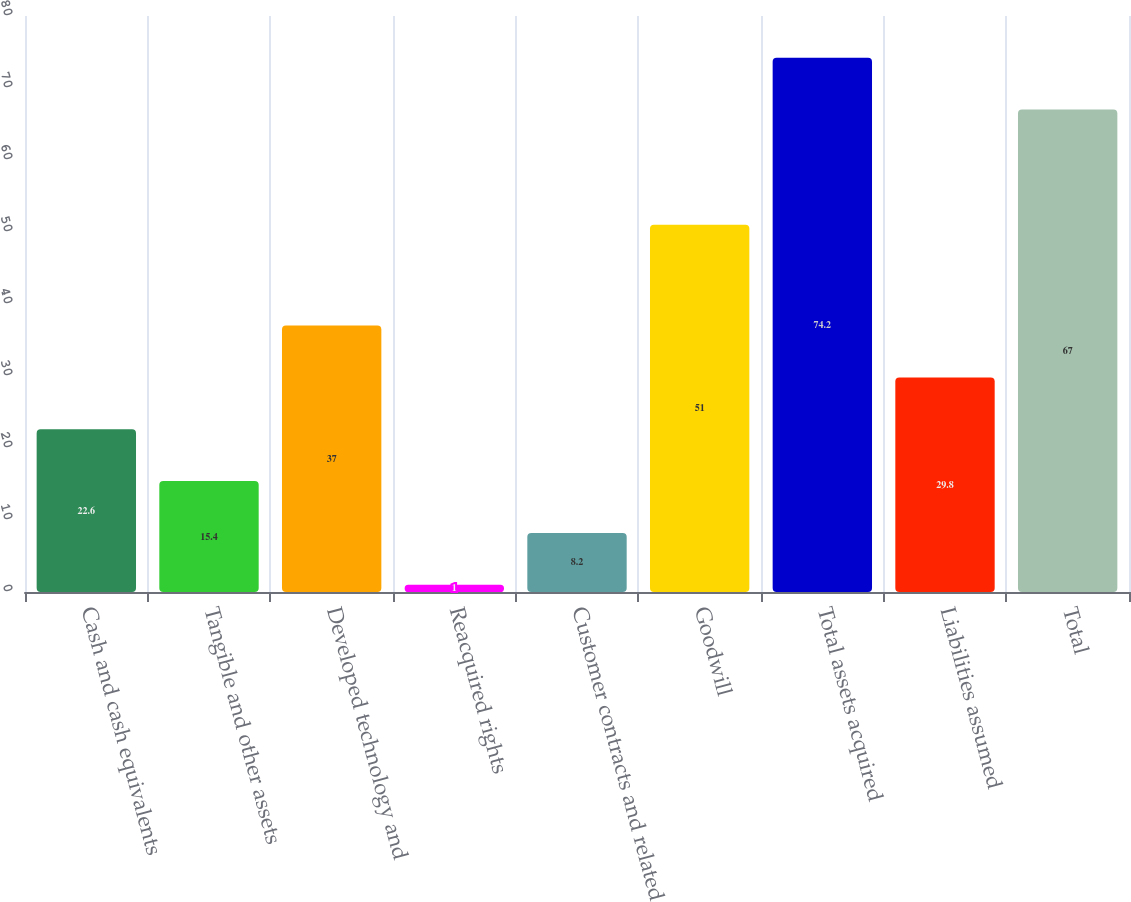Convert chart. <chart><loc_0><loc_0><loc_500><loc_500><bar_chart><fcel>Cash and cash equivalents<fcel>Tangible and other assets<fcel>Developed technology and<fcel>Reacquired rights<fcel>Customer contracts and related<fcel>Goodwill<fcel>Total assets acquired<fcel>Liabilities assumed<fcel>Total<nl><fcel>22.6<fcel>15.4<fcel>37<fcel>1<fcel>8.2<fcel>51<fcel>74.2<fcel>29.8<fcel>67<nl></chart> 